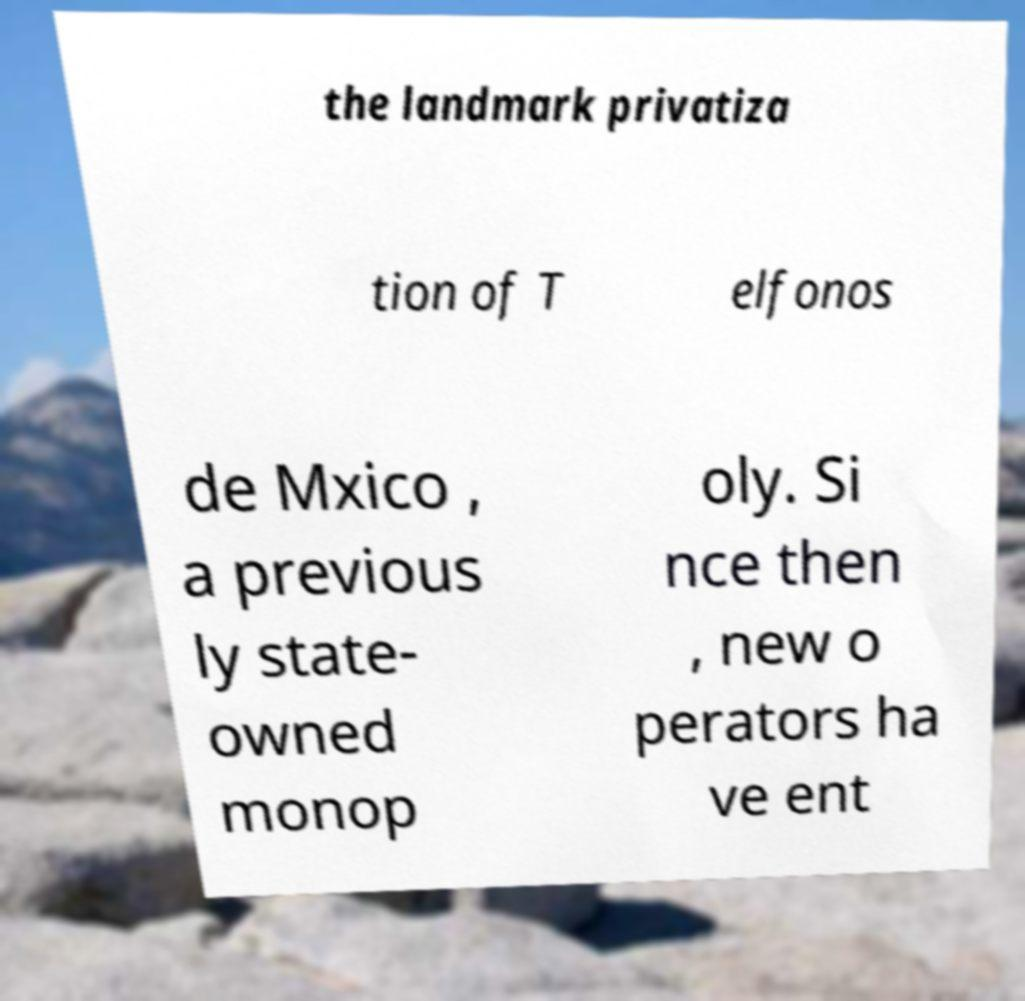Please identify and transcribe the text found in this image. the landmark privatiza tion of T elfonos de Mxico , a previous ly state- owned monop oly. Si nce then , new o perators ha ve ent 